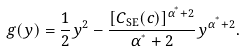<formula> <loc_0><loc_0><loc_500><loc_500>g ( y ) = \frac { 1 } { 2 } y ^ { 2 } - \frac { [ C _ { \text {SE} } ( c ) ] ^ { \alpha ^ { ^ { * } } + 2 } } { \alpha ^ { ^ { * } } + 2 } y ^ { \alpha ^ { ^ { * } } + 2 } .</formula> 